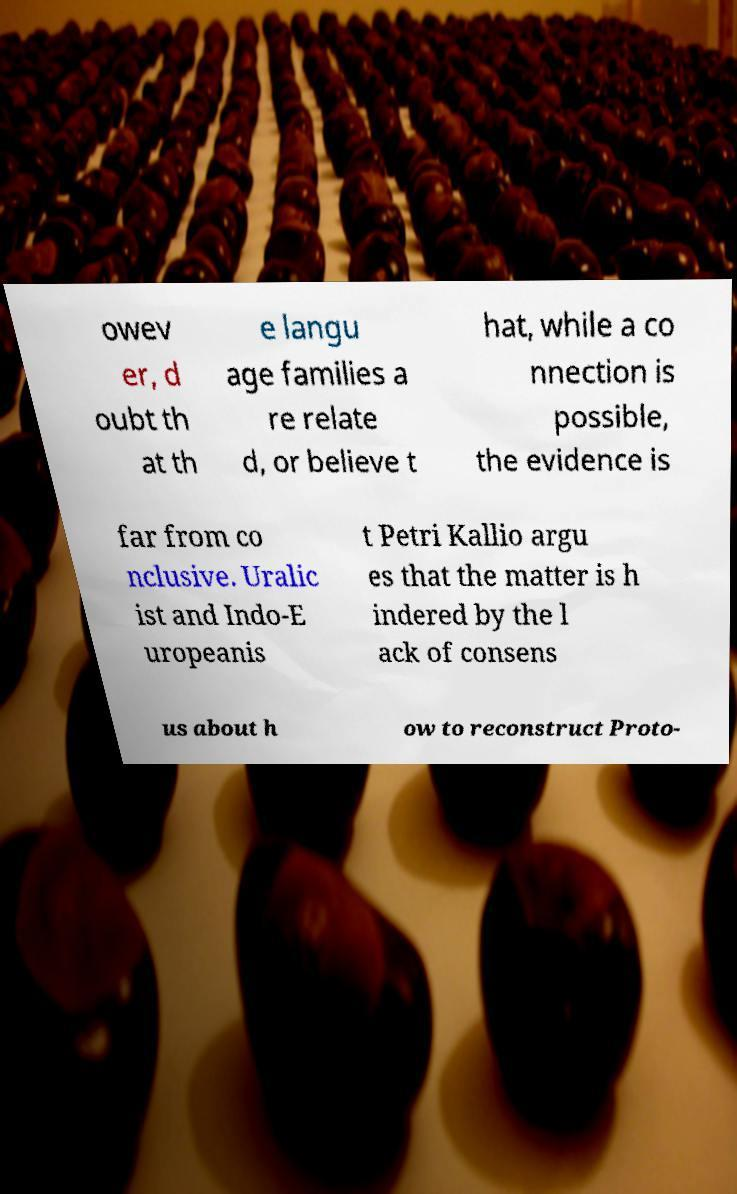Please read and relay the text visible in this image. What does it say? owev er, d oubt th at th e langu age families a re relate d, or believe t hat, while a co nnection is possible, the evidence is far from co nclusive. Uralic ist and Indo-E uropeanis t Petri Kallio argu es that the matter is h indered by the l ack of consens us about h ow to reconstruct Proto- 